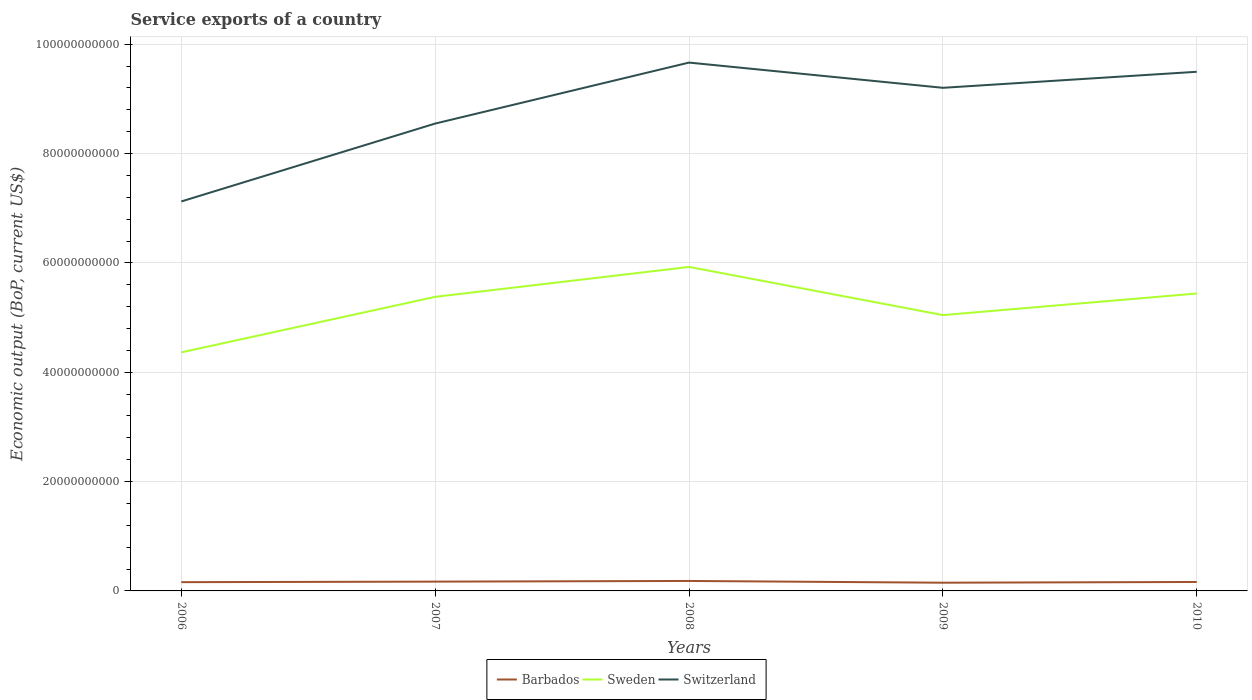Is the number of lines equal to the number of legend labels?
Provide a succinct answer. Yes. Across all years, what is the maximum service exports in Sweden?
Your answer should be compact. 4.36e+1. What is the total service exports in Switzerland in the graph?
Ensure brevity in your answer.  -2.08e+1. What is the difference between the highest and the second highest service exports in Barbados?
Offer a very short reply. 3.19e+08. What is the difference between the highest and the lowest service exports in Sweden?
Offer a terse response. 3. Where does the legend appear in the graph?
Make the answer very short. Bottom center. How are the legend labels stacked?
Provide a short and direct response. Horizontal. What is the title of the graph?
Make the answer very short. Service exports of a country. Does "Denmark" appear as one of the legend labels in the graph?
Offer a very short reply. No. What is the label or title of the X-axis?
Provide a short and direct response. Years. What is the label or title of the Y-axis?
Offer a very short reply. Economic output (BoP, current US$). What is the Economic output (BoP, current US$) of Barbados in 2006?
Make the answer very short. 1.60e+09. What is the Economic output (BoP, current US$) in Sweden in 2006?
Offer a very short reply. 4.36e+1. What is the Economic output (BoP, current US$) of Switzerland in 2006?
Your answer should be compact. 7.12e+1. What is the Economic output (BoP, current US$) in Barbados in 2007?
Your response must be concise. 1.70e+09. What is the Economic output (BoP, current US$) of Sweden in 2007?
Your response must be concise. 5.38e+1. What is the Economic output (BoP, current US$) of Switzerland in 2007?
Ensure brevity in your answer.  8.55e+1. What is the Economic output (BoP, current US$) in Barbados in 2008?
Offer a very short reply. 1.82e+09. What is the Economic output (BoP, current US$) in Sweden in 2008?
Your answer should be very brief. 5.93e+1. What is the Economic output (BoP, current US$) of Switzerland in 2008?
Provide a succinct answer. 9.66e+1. What is the Economic output (BoP, current US$) in Barbados in 2009?
Give a very brief answer. 1.50e+09. What is the Economic output (BoP, current US$) of Sweden in 2009?
Ensure brevity in your answer.  5.05e+1. What is the Economic output (BoP, current US$) in Switzerland in 2009?
Keep it short and to the point. 9.20e+1. What is the Economic output (BoP, current US$) of Barbados in 2010?
Keep it short and to the point. 1.64e+09. What is the Economic output (BoP, current US$) of Sweden in 2010?
Your answer should be very brief. 5.44e+1. What is the Economic output (BoP, current US$) in Switzerland in 2010?
Provide a succinct answer. 9.50e+1. Across all years, what is the maximum Economic output (BoP, current US$) in Barbados?
Keep it short and to the point. 1.82e+09. Across all years, what is the maximum Economic output (BoP, current US$) of Sweden?
Give a very brief answer. 5.93e+1. Across all years, what is the maximum Economic output (BoP, current US$) of Switzerland?
Provide a succinct answer. 9.66e+1. Across all years, what is the minimum Economic output (BoP, current US$) in Barbados?
Ensure brevity in your answer.  1.50e+09. Across all years, what is the minimum Economic output (BoP, current US$) in Sweden?
Offer a very short reply. 4.36e+1. Across all years, what is the minimum Economic output (BoP, current US$) in Switzerland?
Provide a short and direct response. 7.12e+1. What is the total Economic output (BoP, current US$) of Barbados in the graph?
Provide a short and direct response. 8.27e+09. What is the total Economic output (BoP, current US$) of Sweden in the graph?
Offer a terse response. 2.62e+11. What is the total Economic output (BoP, current US$) in Switzerland in the graph?
Make the answer very short. 4.40e+11. What is the difference between the Economic output (BoP, current US$) of Barbados in 2006 and that in 2007?
Offer a terse response. -9.73e+07. What is the difference between the Economic output (BoP, current US$) in Sweden in 2006 and that in 2007?
Ensure brevity in your answer.  -1.02e+1. What is the difference between the Economic output (BoP, current US$) of Switzerland in 2006 and that in 2007?
Ensure brevity in your answer.  -1.42e+1. What is the difference between the Economic output (BoP, current US$) of Barbados in 2006 and that in 2008?
Give a very brief answer. -2.19e+08. What is the difference between the Economic output (BoP, current US$) of Sweden in 2006 and that in 2008?
Offer a very short reply. -1.56e+1. What is the difference between the Economic output (BoP, current US$) in Switzerland in 2006 and that in 2008?
Your response must be concise. -2.54e+1. What is the difference between the Economic output (BoP, current US$) in Barbados in 2006 and that in 2009?
Provide a succinct answer. 9.98e+07. What is the difference between the Economic output (BoP, current US$) in Sweden in 2006 and that in 2009?
Keep it short and to the point. -6.81e+09. What is the difference between the Economic output (BoP, current US$) of Switzerland in 2006 and that in 2009?
Your answer should be very brief. -2.08e+1. What is the difference between the Economic output (BoP, current US$) in Barbados in 2006 and that in 2010?
Provide a succinct answer. -3.48e+07. What is the difference between the Economic output (BoP, current US$) in Sweden in 2006 and that in 2010?
Keep it short and to the point. -1.08e+1. What is the difference between the Economic output (BoP, current US$) of Switzerland in 2006 and that in 2010?
Your answer should be compact. -2.37e+1. What is the difference between the Economic output (BoP, current US$) in Barbados in 2007 and that in 2008?
Keep it short and to the point. -1.22e+08. What is the difference between the Economic output (BoP, current US$) of Sweden in 2007 and that in 2008?
Keep it short and to the point. -5.47e+09. What is the difference between the Economic output (BoP, current US$) of Switzerland in 2007 and that in 2008?
Offer a terse response. -1.12e+1. What is the difference between the Economic output (BoP, current US$) in Barbados in 2007 and that in 2009?
Ensure brevity in your answer.  1.97e+08. What is the difference between the Economic output (BoP, current US$) in Sweden in 2007 and that in 2009?
Offer a very short reply. 3.34e+09. What is the difference between the Economic output (BoP, current US$) of Switzerland in 2007 and that in 2009?
Offer a terse response. -6.54e+09. What is the difference between the Economic output (BoP, current US$) in Barbados in 2007 and that in 2010?
Keep it short and to the point. 6.25e+07. What is the difference between the Economic output (BoP, current US$) of Sweden in 2007 and that in 2010?
Ensure brevity in your answer.  -6.12e+08. What is the difference between the Economic output (BoP, current US$) of Switzerland in 2007 and that in 2010?
Your response must be concise. -9.47e+09. What is the difference between the Economic output (BoP, current US$) in Barbados in 2008 and that in 2009?
Provide a short and direct response. 3.19e+08. What is the difference between the Economic output (BoP, current US$) of Sweden in 2008 and that in 2009?
Make the answer very short. 8.81e+09. What is the difference between the Economic output (BoP, current US$) in Switzerland in 2008 and that in 2009?
Offer a very short reply. 4.61e+09. What is the difference between the Economic output (BoP, current US$) in Barbados in 2008 and that in 2010?
Offer a terse response. 1.84e+08. What is the difference between the Economic output (BoP, current US$) of Sweden in 2008 and that in 2010?
Provide a short and direct response. 4.86e+09. What is the difference between the Economic output (BoP, current US$) in Switzerland in 2008 and that in 2010?
Keep it short and to the point. 1.68e+09. What is the difference between the Economic output (BoP, current US$) in Barbados in 2009 and that in 2010?
Offer a terse response. -1.35e+08. What is the difference between the Economic output (BoP, current US$) of Sweden in 2009 and that in 2010?
Offer a terse response. -3.95e+09. What is the difference between the Economic output (BoP, current US$) of Switzerland in 2009 and that in 2010?
Your response must be concise. -2.93e+09. What is the difference between the Economic output (BoP, current US$) of Barbados in 2006 and the Economic output (BoP, current US$) of Sweden in 2007?
Make the answer very short. -5.22e+1. What is the difference between the Economic output (BoP, current US$) in Barbados in 2006 and the Economic output (BoP, current US$) in Switzerland in 2007?
Your answer should be very brief. -8.39e+1. What is the difference between the Economic output (BoP, current US$) in Sweden in 2006 and the Economic output (BoP, current US$) in Switzerland in 2007?
Your response must be concise. -4.18e+1. What is the difference between the Economic output (BoP, current US$) of Barbados in 2006 and the Economic output (BoP, current US$) of Sweden in 2008?
Provide a succinct answer. -5.77e+1. What is the difference between the Economic output (BoP, current US$) of Barbados in 2006 and the Economic output (BoP, current US$) of Switzerland in 2008?
Your answer should be compact. -9.50e+1. What is the difference between the Economic output (BoP, current US$) in Sweden in 2006 and the Economic output (BoP, current US$) in Switzerland in 2008?
Your response must be concise. -5.30e+1. What is the difference between the Economic output (BoP, current US$) of Barbados in 2006 and the Economic output (BoP, current US$) of Sweden in 2009?
Offer a terse response. -4.89e+1. What is the difference between the Economic output (BoP, current US$) of Barbados in 2006 and the Economic output (BoP, current US$) of Switzerland in 2009?
Offer a very short reply. -9.04e+1. What is the difference between the Economic output (BoP, current US$) of Sweden in 2006 and the Economic output (BoP, current US$) of Switzerland in 2009?
Ensure brevity in your answer.  -4.84e+1. What is the difference between the Economic output (BoP, current US$) in Barbados in 2006 and the Economic output (BoP, current US$) in Sweden in 2010?
Make the answer very short. -5.28e+1. What is the difference between the Economic output (BoP, current US$) in Barbados in 2006 and the Economic output (BoP, current US$) in Switzerland in 2010?
Provide a short and direct response. -9.34e+1. What is the difference between the Economic output (BoP, current US$) in Sweden in 2006 and the Economic output (BoP, current US$) in Switzerland in 2010?
Keep it short and to the point. -5.13e+1. What is the difference between the Economic output (BoP, current US$) of Barbados in 2007 and the Economic output (BoP, current US$) of Sweden in 2008?
Offer a terse response. -5.76e+1. What is the difference between the Economic output (BoP, current US$) in Barbados in 2007 and the Economic output (BoP, current US$) in Switzerland in 2008?
Provide a short and direct response. -9.49e+1. What is the difference between the Economic output (BoP, current US$) in Sweden in 2007 and the Economic output (BoP, current US$) in Switzerland in 2008?
Keep it short and to the point. -4.29e+1. What is the difference between the Economic output (BoP, current US$) of Barbados in 2007 and the Economic output (BoP, current US$) of Sweden in 2009?
Provide a succinct answer. -4.88e+1. What is the difference between the Economic output (BoP, current US$) of Barbados in 2007 and the Economic output (BoP, current US$) of Switzerland in 2009?
Ensure brevity in your answer.  -9.03e+1. What is the difference between the Economic output (BoP, current US$) of Sweden in 2007 and the Economic output (BoP, current US$) of Switzerland in 2009?
Give a very brief answer. -3.82e+1. What is the difference between the Economic output (BoP, current US$) in Barbados in 2007 and the Economic output (BoP, current US$) in Sweden in 2010?
Make the answer very short. -5.27e+1. What is the difference between the Economic output (BoP, current US$) in Barbados in 2007 and the Economic output (BoP, current US$) in Switzerland in 2010?
Your response must be concise. -9.33e+1. What is the difference between the Economic output (BoP, current US$) in Sweden in 2007 and the Economic output (BoP, current US$) in Switzerland in 2010?
Your answer should be compact. -4.12e+1. What is the difference between the Economic output (BoP, current US$) of Barbados in 2008 and the Economic output (BoP, current US$) of Sweden in 2009?
Keep it short and to the point. -4.86e+1. What is the difference between the Economic output (BoP, current US$) in Barbados in 2008 and the Economic output (BoP, current US$) in Switzerland in 2009?
Your answer should be compact. -9.02e+1. What is the difference between the Economic output (BoP, current US$) in Sweden in 2008 and the Economic output (BoP, current US$) in Switzerland in 2009?
Give a very brief answer. -3.28e+1. What is the difference between the Economic output (BoP, current US$) in Barbados in 2008 and the Economic output (BoP, current US$) in Sweden in 2010?
Provide a short and direct response. -5.26e+1. What is the difference between the Economic output (BoP, current US$) in Barbados in 2008 and the Economic output (BoP, current US$) in Switzerland in 2010?
Ensure brevity in your answer.  -9.31e+1. What is the difference between the Economic output (BoP, current US$) of Sweden in 2008 and the Economic output (BoP, current US$) of Switzerland in 2010?
Your response must be concise. -3.57e+1. What is the difference between the Economic output (BoP, current US$) of Barbados in 2009 and the Economic output (BoP, current US$) of Sweden in 2010?
Your response must be concise. -5.29e+1. What is the difference between the Economic output (BoP, current US$) of Barbados in 2009 and the Economic output (BoP, current US$) of Switzerland in 2010?
Ensure brevity in your answer.  -9.35e+1. What is the difference between the Economic output (BoP, current US$) in Sweden in 2009 and the Economic output (BoP, current US$) in Switzerland in 2010?
Ensure brevity in your answer.  -4.45e+1. What is the average Economic output (BoP, current US$) of Barbados per year?
Provide a succinct answer. 1.65e+09. What is the average Economic output (BoP, current US$) in Sweden per year?
Keep it short and to the point. 5.23e+1. What is the average Economic output (BoP, current US$) of Switzerland per year?
Your answer should be very brief. 8.81e+1. In the year 2006, what is the difference between the Economic output (BoP, current US$) in Barbados and Economic output (BoP, current US$) in Sweden?
Make the answer very short. -4.20e+1. In the year 2006, what is the difference between the Economic output (BoP, current US$) in Barbados and Economic output (BoP, current US$) in Switzerland?
Your answer should be compact. -6.96e+1. In the year 2006, what is the difference between the Economic output (BoP, current US$) in Sweden and Economic output (BoP, current US$) in Switzerland?
Ensure brevity in your answer.  -2.76e+1. In the year 2007, what is the difference between the Economic output (BoP, current US$) of Barbados and Economic output (BoP, current US$) of Sweden?
Ensure brevity in your answer.  -5.21e+1. In the year 2007, what is the difference between the Economic output (BoP, current US$) of Barbados and Economic output (BoP, current US$) of Switzerland?
Your answer should be compact. -8.38e+1. In the year 2007, what is the difference between the Economic output (BoP, current US$) of Sweden and Economic output (BoP, current US$) of Switzerland?
Offer a very short reply. -3.17e+1. In the year 2008, what is the difference between the Economic output (BoP, current US$) of Barbados and Economic output (BoP, current US$) of Sweden?
Make the answer very short. -5.74e+1. In the year 2008, what is the difference between the Economic output (BoP, current US$) of Barbados and Economic output (BoP, current US$) of Switzerland?
Make the answer very short. -9.48e+1. In the year 2008, what is the difference between the Economic output (BoP, current US$) in Sweden and Economic output (BoP, current US$) in Switzerland?
Your answer should be very brief. -3.74e+1. In the year 2009, what is the difference between the Economic output (BoP, current US$) in Barbados and Economic output (BoP, current US$) in Sweden?
Provide a succinct answer. -4.90e+1. In the year 2009, what is the difference between the Economic output (BoP, current US$) in Barbados and Economic output (BoP, current US$) in Switzerland?
Your answer should be very brief. -9.05e+1. In the year 2009, what is the difference between the Economic output (BoP, current US$) of Sweden and Economic output (BoP, current US$) of Switzerland?
Offer a terse response. -4.16e+1. In the year 2010, what is the difference between the Economic output (BoP, current US$) in Barbados and Economic output (BoP, current US$) in Sweden?
Make the answer very short. -5.28e+1. In the year 2010, what is the difference between the Economic output (BoP, current US$) in Barbados and Economic output (BoP, current US$) in Switzerland?
Your answer should be very brief. -9.33e+1. In the year 2010, what is the difference between the Economic output (BoP, current US$) in Sweden and Economic output (BoP, current US$) in Switzerland?
Provide a succinct answer. -4.06e+1. What is the ratio of the Economic output (BoP, current US$) in Barbados in 2006 to that in 2007?
Make the answer very short. 0.94. What is the ratio of the Economic output (BoP, current US$) in Sweden in 2006 to that in 2007?
Your response must be concise. 0.81. What is the ratio of the Economic output (BoP, current US$) of Barbados in 2006 to that in 2008?
Provide a succinct answer. 0.88. What is the ratio of the Economic output (BoP, current US$) of Sweden in 2006 to that in 2008?
Provide a succinct answer. 0.74. What is the ratio of the Economic output (BoP, current US$) of Switzerland in 2006 to that in 2008?
Provide a short and direct response. 0.74. What is the ratio of the Economic output (BoP, current US$) in Barbados in 2006 to that in 2009?
Give a very brief answer. 1.07. What is the ratio of the Economic output (BoP, current US$) of Sweden in 2006 to that in 2009?
Your answer should be very brief. 0.86. What is the ratio of the Economic output (BoP, current US$) in Switzerland in 2006 to that in 2009?
Offer a very short reply. 0.77. What is the ratio of the Economic output (BoP, current US$) in Barbados in 2006 to that in 2010?
Ensure brevity in your answer.  0.98. What is the ratio of the Economic output (BoP, current US$) in Sweden in 2006 to that in 2010?
Provide a short and direct response. 0.8. What is the ratio of the Economic output (BoP, current US$) in Switzerland in 2006 to that in 2010?
Your answer should be compact. 0.75. What is the ratio of the Economic output (BoP, current US$) in Barbados in 2007 to that in 2008?
Offer a terse response. 0.93. What is the ratio of the Economic output (BoP, current US$) of Sweden in 2007 to that in 2008?
Provide a short and direct response. 0.91. What is the ratio of the Economic output (BoP, current US$) of Switzerland in 2007 to that in 2008?
Your response must be concise. 0.88. What is the ratio of the Economic output (BoP, current US$) in Barbados in 2007 to that in 2009?
Offer a very short reply. 1.13. What is the ratio of the Economic output (BoP, current US$) in Sweden in 2007 to that in 2009?
Keep it short and to the point. 1.07. What is the ratio of the Economic output (BoP, current US$) in Switzerland in 2007 to that in 2009?
Make the answer very short. 0.93. What is the ratio of the Economic output (BoP, current US$) of Barbados in 2007 to that in 2010?
Offer a terse response. 1.04. What is the ratio of the Economic output (BoP, current US$) of Sweden in 2007 to that in 2010?
Keep it short and to the point. 0.99. What is the ratio of the Economic output (BoP, current US$) in Switzerland in 2007 to that in 2010?
Your response must be concise. 0.9. What is the ratio of the Economic output (BoP, current US$) in Barbados in 2008 to that in 2009?
Your answer should be very brief. 1.21. What is the ratio of the Economic output (BoP, current US$) of Sweden in 2008 to that in 2009?
Keep it short and to the point. 1.17. What is the ratio of the Economic output (BoP, current US$) in Switzerland in 2008 to that in 2009?
Give a very brief answer. 1.05. What is the ratio of the Economic output (BoP, current US$) of Barbados in 2008 to that in 2010?
Your answer should be compact. 1.11. What is the ratio of the Economic output (BoP, current US$) in Sweden in 2008 to that in 2010?
Keep it short and to the point. 1.09. What is the ratio of the Economic output (BoP, current US$) in Switzerland in 2008 to that in 2010?
Offer a very short reply. 1.02. What is the ratio of the Economic output (BoP, current US$) in Barbados in 2009 to that in 2010?
Provide a succinct answer. 0.92. What is the ratio of the Economic output (BoP, current US$) in Sweden in 2009 to that in 2010?
Keep it short and to the point. 0.93. What is the ratio of the Economic output (BoP, current US$) in Switzerland in 2009 to that in 2010?
Make the answer very short. 0.97. What is the difference between the highest and the second highest Economic output (BoP, current US$) of Barbados?
Give a very brief answer. 1.22e+08. What is the difference between the highest and the second highest Economic output (BoP, current US$) of Sweden?
Ensure brevity in your answer.  4.86e+09. What is the difference between the highest and the second highest Economic output (BoP, current US$) of Switzerland?
Keep it short and to the point. 1.68e+09. What is the difference between the highest and the lowest Economic output (BoP, current US$) of Barbados?
Offer a very short reply. 3.19e+08. What is the difference between the highest and the lowest Economic output (BoP, current US$) in Sweden?
Your answer should be very brief. 1.56e+1. What is the difference between the highest and the lowest Economic output (BoP, current US$) in Switzerland?
Provide a succinct answer. 2.54e+1. 